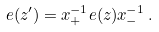<formula> <loc_0><loc_0><loc_500><loc_500>e ( z ^ { \prime } ) = x _ { + } ^ { - 1 } e ( z ) x _ { - } ^ { - 1 } \, .</formula> 